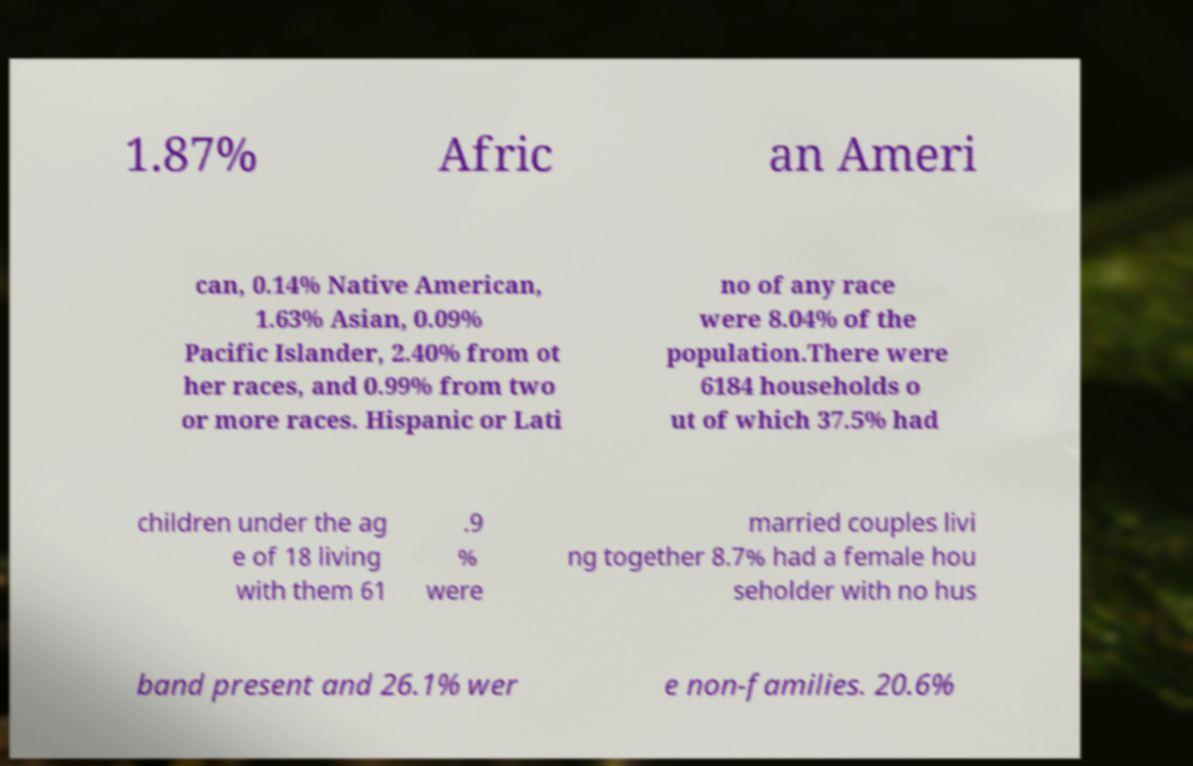Can you read and provide the text displayed in the image?This photo seems to have some interesting text. Can you extract and type it out for me? 1.87% Afric an Ameri can, 0.14% Native American, 1.63% Asian, 0.09% Pacific Islander, 2.40% from ot her races, and 0.99% from two or more races. Hispanic or Lati no of any race were 8.04% of the population.There were 6184 households o ut of which 37.5% had children under the ag e of 18 living with them 61 .9 % were married couples livi ng together 8.7% had a female hou seholder with no hus band present and 26.1% wer e non-families. 20.6% 